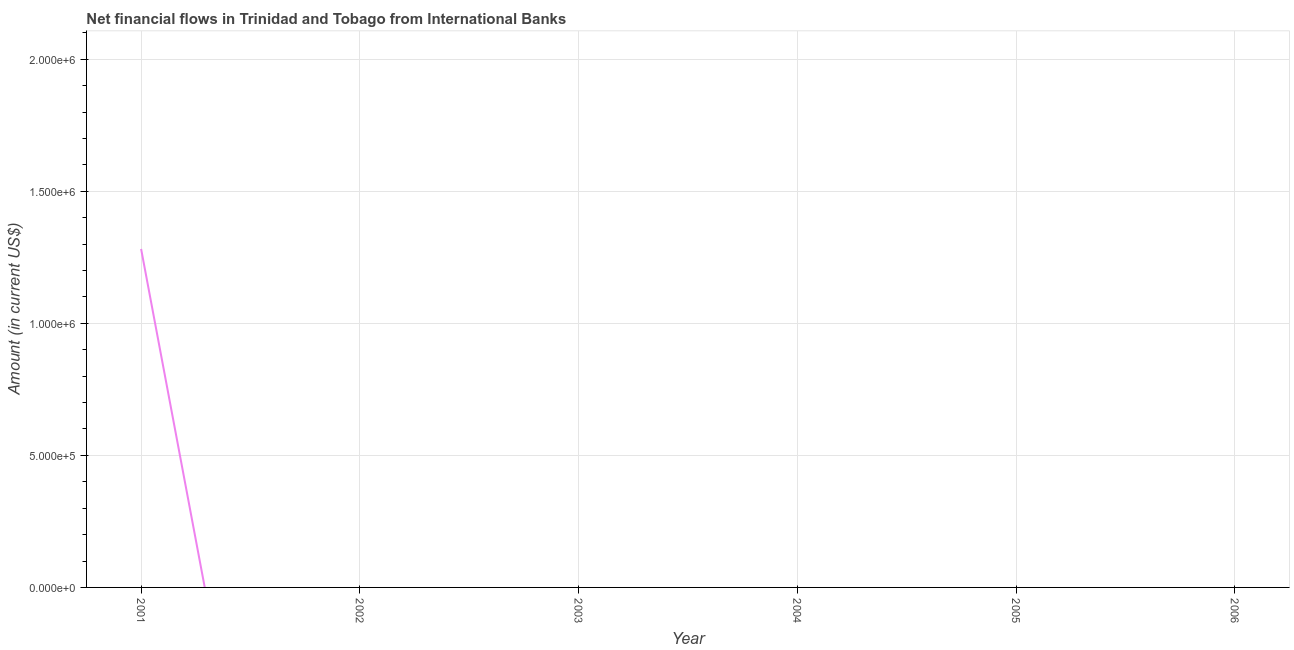What is the net financial flows from ibrd in 2002?
Keep it short and to the point. 0. Across all years, what is the maximum net financial flows from ibrd?
Your response must be concise. 1.28e+06. Across all years, what is the minimum net financial flows from ibrd?
Offer a terse response. 0. What is the sum of the net financial flows from ibrd?
Your response must be concise. 1.28e+06. What is the average net financial flows from ibrd per year?
Keep it short and to the point. 2.14e+05. In how many years, is the net financial flows from ibrd greater than 1800000 US$?
Your response must be concise. 0. What is the difference between the highest and the lowest net financial flows from ibrd?
Make the answer very short. 1.28e+06. Does the net financial flows from ibrd monotonically increase over the years?
Provide a succinct answer. No. How many lines are there?
Provide a short and direct response. 1. How many years are there in the graph?
Your response must be concise. 6. What is the difference between two consecutive major ticks on the Y-axis?
Provide a short and direct response. 5.00e+05. Are the values on the major ticks of Y-axis written in scientific E-notation?
Your answer should be very brief. Yes. Does the graph contain any zero values?
Make the answer very short. Yes. What is the title of the graph?
Provide a succinct answer. Net financial flows in Trinidad and Tobago from International Banks. What is the label or title of the X-axis?
Your response must be concise. Year. What is the label or title of the Y-axis?
Give a very brief answer. Amount (in current US$). What is the Amount (in current US$) of 2001?
Your response must be concise. 1.28e+06. What is the Amount (in current US$) in 2002?
Ensure brevity in your answer.  0. What is the Amount (in current US$) of 2003?
Give a very brief answer. 0. What is the Amount (in current US$) of 2006?
Give a very brief answer. 0. 